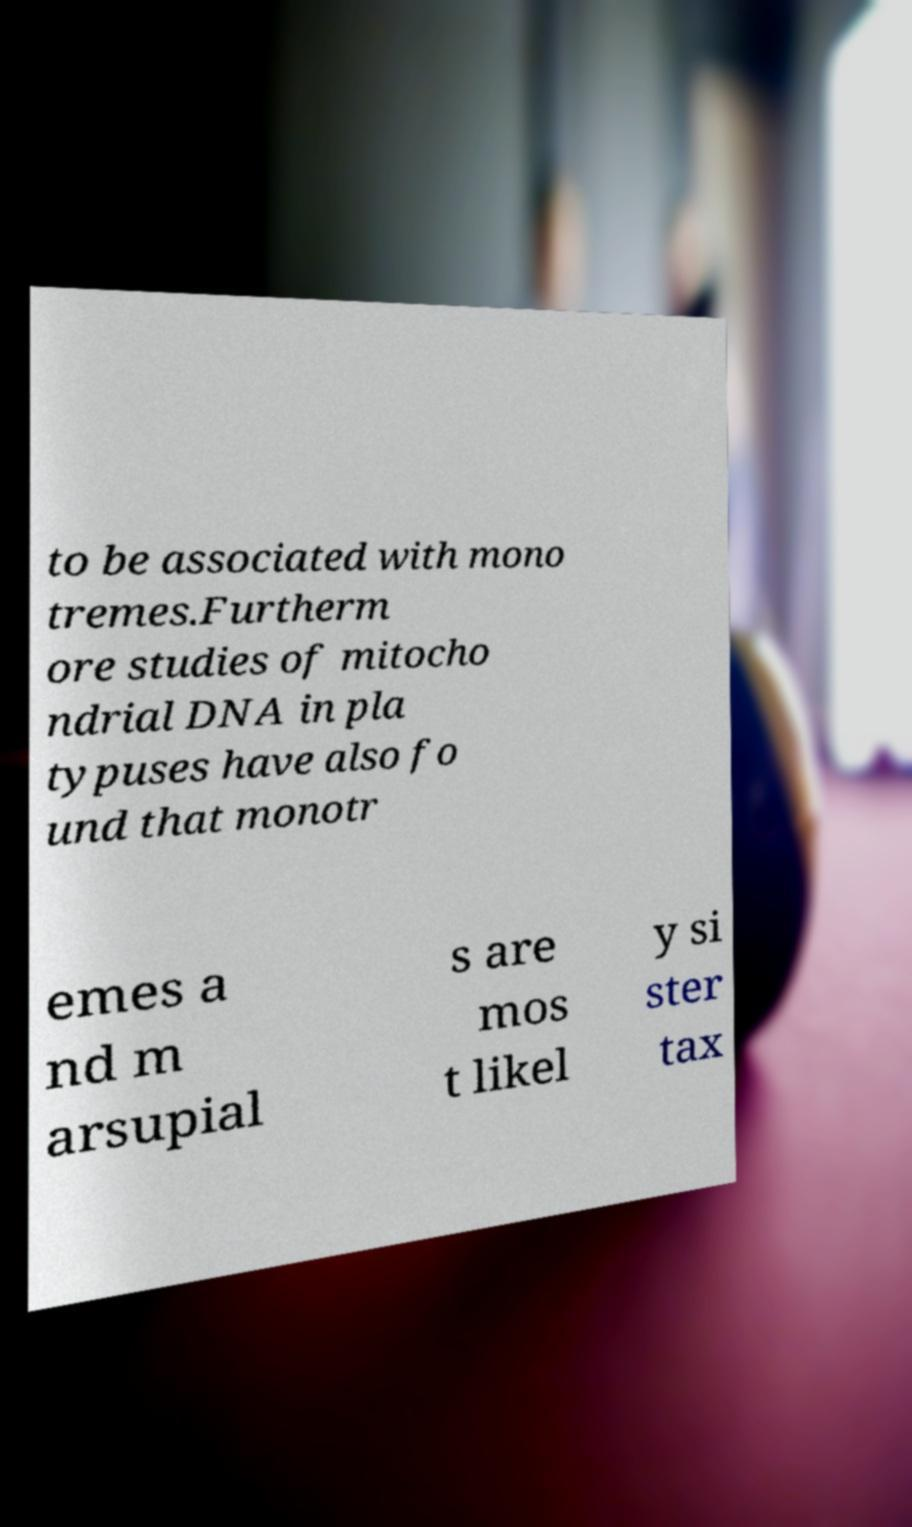What messages or text are displayed in this image? I need them in a readable, typed format. to be associated with mono tremes.Furtherm ore studies of mitocho ndrial DNA in pla typuses have also fo und that monotr emes a nd m arsupial s are mos t likel y si ster tax 